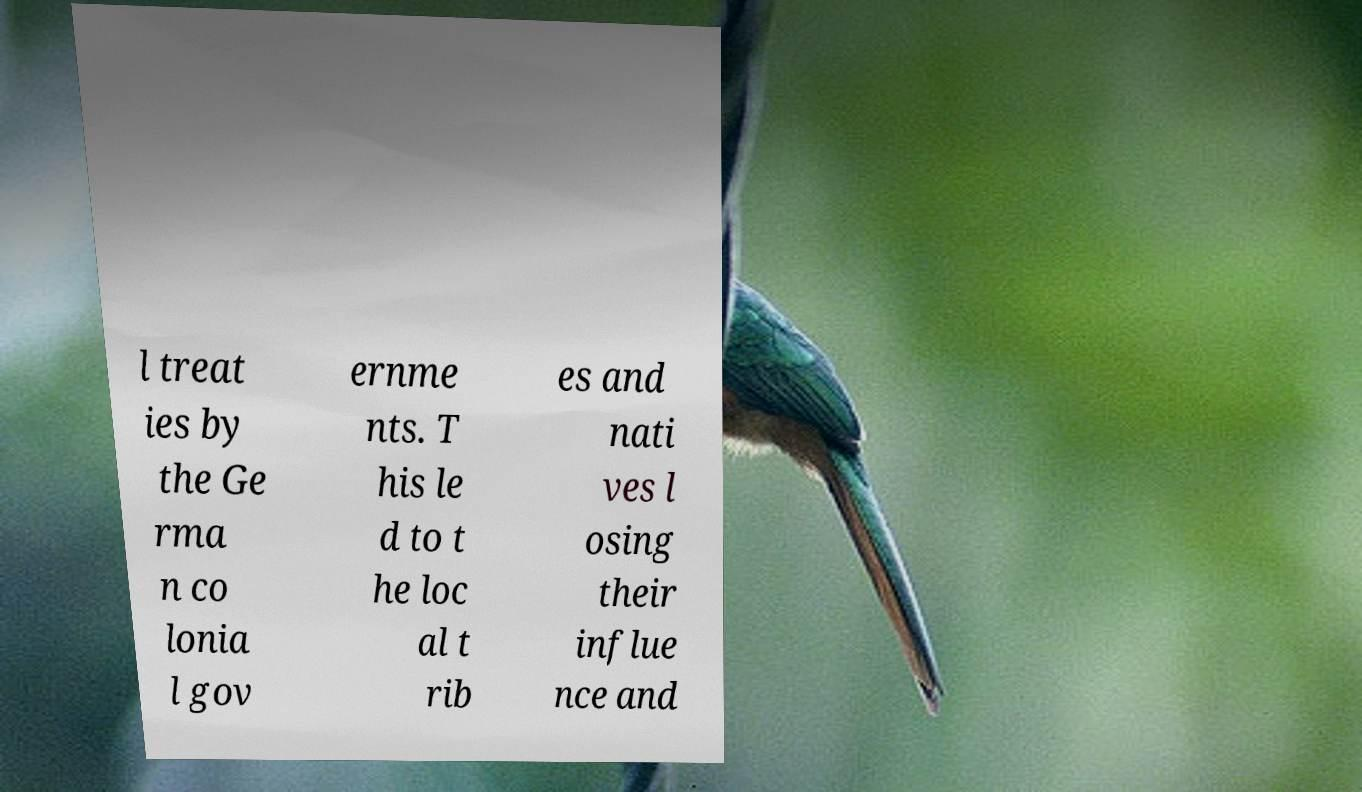Can you accurately transcribe the text from the provided image for me? l treat ies by the Ge rma n co lonia l gov ernme nts. T his le d to t he loc al t rib es and nati ves l osing their influe nce and 